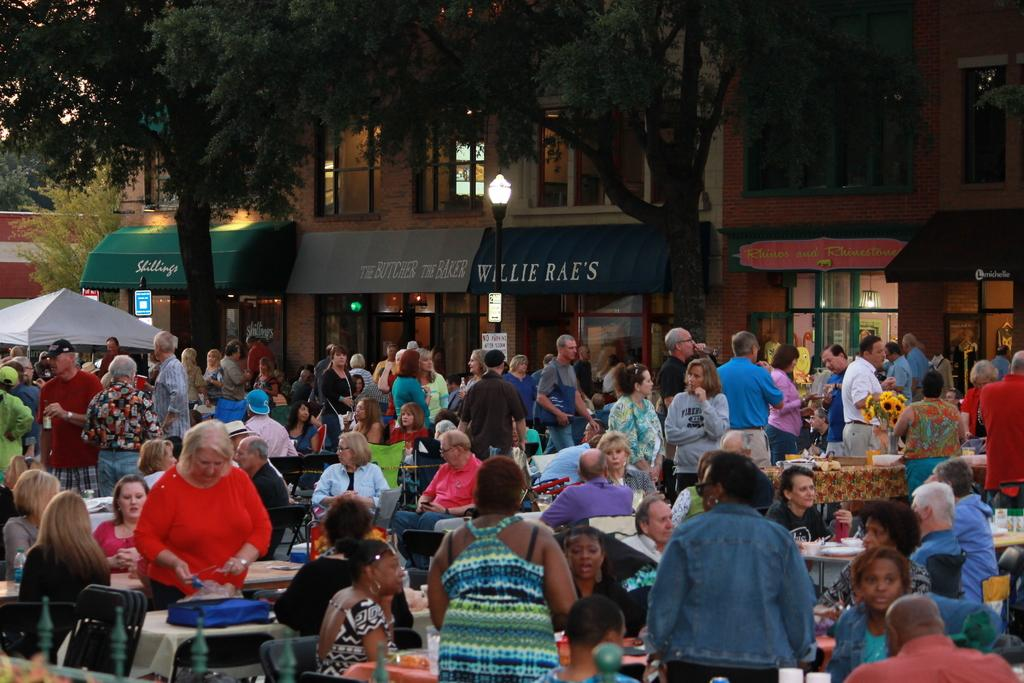How many people are in the image? There is a group of people in the image, but the exact number is not specified. What are the people in the image doing? Some people are sitting, while others are standing. What can be seen in the background of the image? There is a building and trees in the background of the image. What type of dust can be seen on the people's clothes in the image? There is no dust visible on the people's clothes in the image. How does the operation of the building in the background affect the people in the image? The image does not provide any information about the operation of the building or its potential impact on the people. 